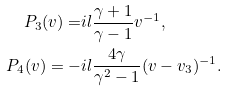<formula> <loc_0><loc_0><loc_500><loc_500>P _ { 3 } ( v ) = & i l \frac { \gamma + 1 } { \gamma - 1 } v ^ { - 1 } , \\ P _ { 4 } ( v ) = - & i l \frac { 4 \gamma } { \gamma ^ { 2 } - 1 } ( v - v _ { 3 } ) ^ { - 1 } .</formula> 